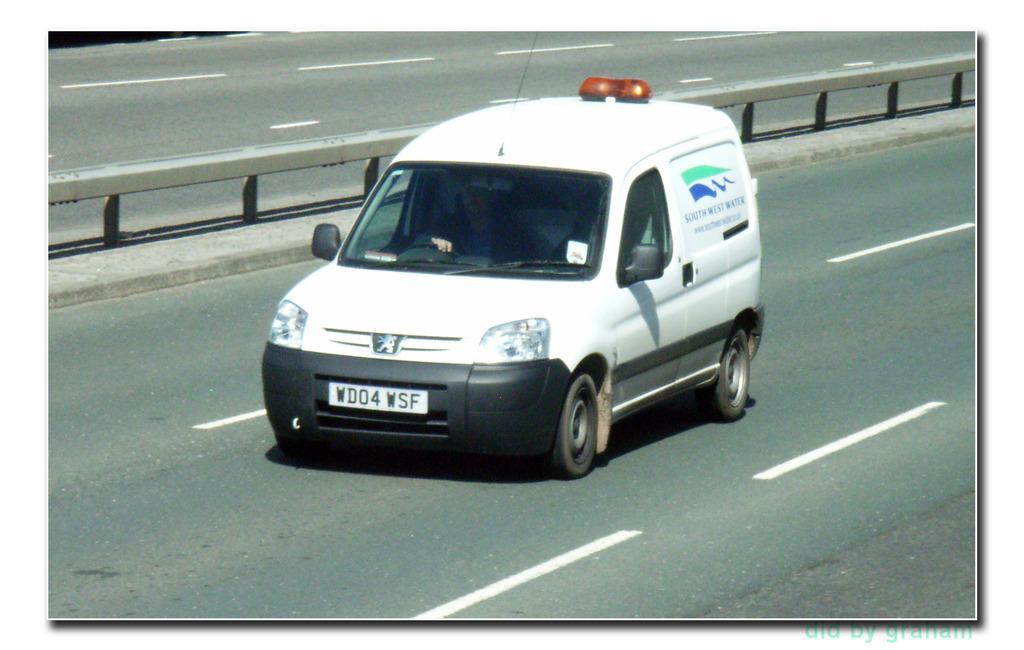Please provide a concise description of this image. In this image I can see the vehicle on the road. The vehicle is in white color and I can see the number plate to it. I can also see the person inside the vehicle. To the right of the vehicle I can see the railing. 